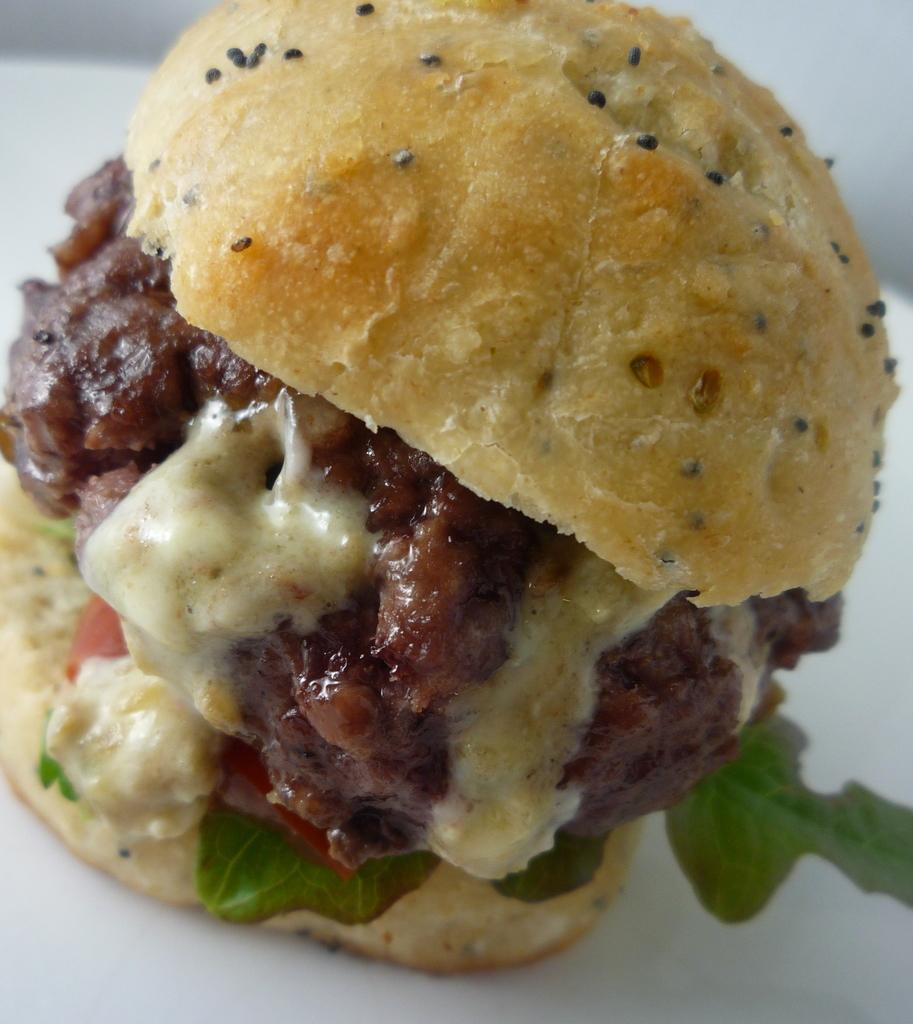What is the main food item in the image? There is a burger in the image. What are the main components of the burger? The burger consists of bread, patty, cheese, and spinach. Are there any additional ingredients in the burger? Yes, there are other ingredients in the burger. What color is the background of the image? The background of the image appears to be white in color. How does the zebra contribute to the value of the burger in the image? There is no zebra present in the image, so it cannot contribute to the value of the burger. 